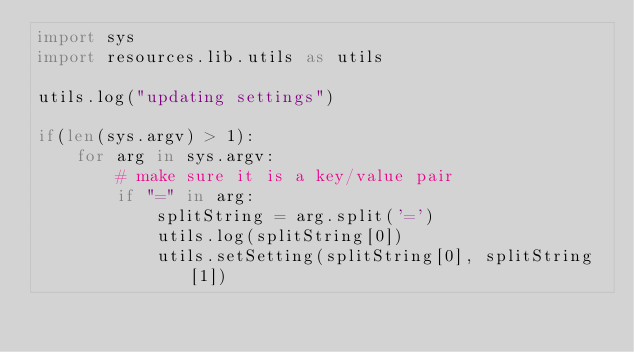<code> <loc_0><loc_0><loc_500><loc_500><_Python_>import sys
import resources.lib.utils as utils

utils.log("updating settings")

if(len(sys.argv) > 1):
    for arg in sys.argv:
        # make sure it is a key/value pair
        if "=" in arg:
            splitString = arg.split('=')
            utils.log(splitString[0])
            utils.setSetting(splitString[0], splitString[1])
</code> 